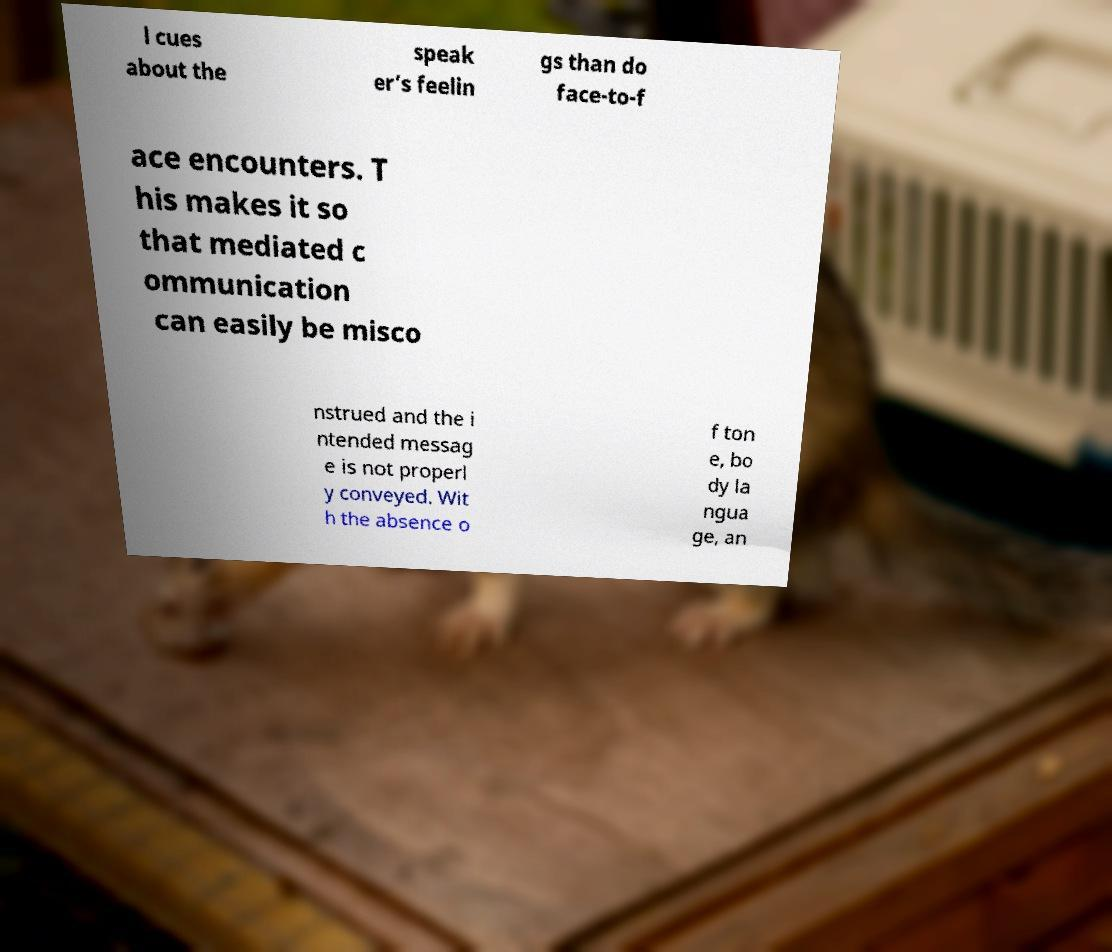Please identify and transcribe the text found in this image. l cues about the speak er’s feelin gs than do face-to-f ace encounters. T his makes it so that mediated c ommunication can easily be misco nstrued and the i ntended messag e is not properl y conveyed. Wit h the absence o f ton e, bo dy la ngua ge, an 